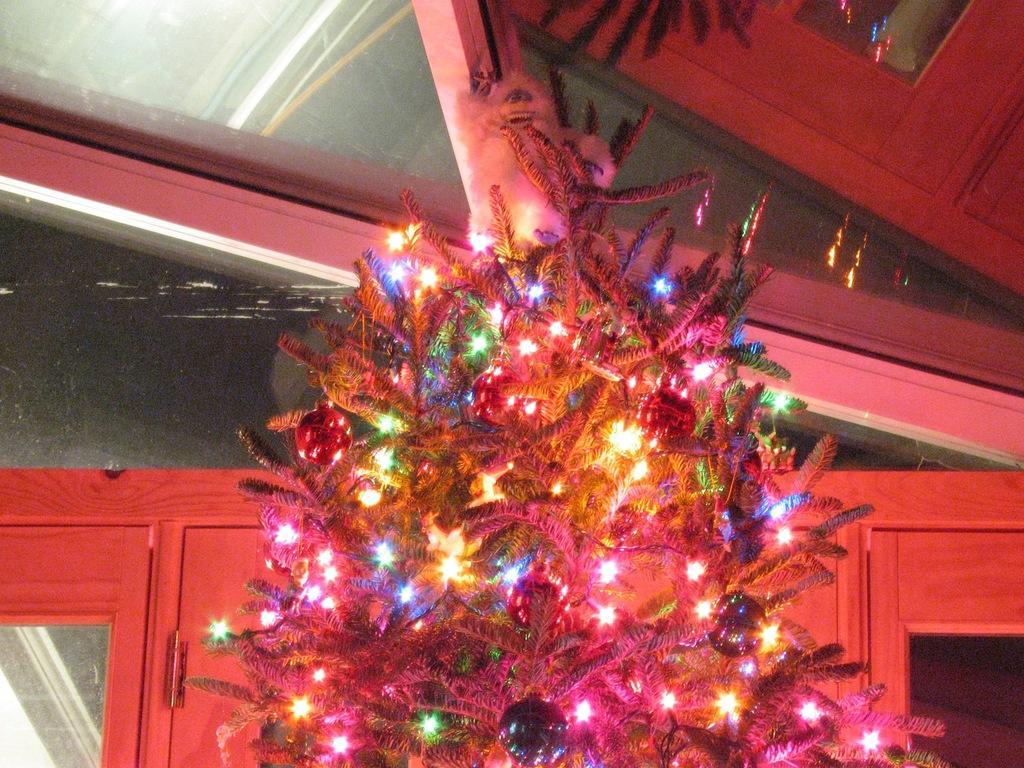In one or two sentences, can you explain what this image depicts? In this image I can see the Christmas tree and I can see few decorative items and few lights in multi color, background I can see few glass doors. 